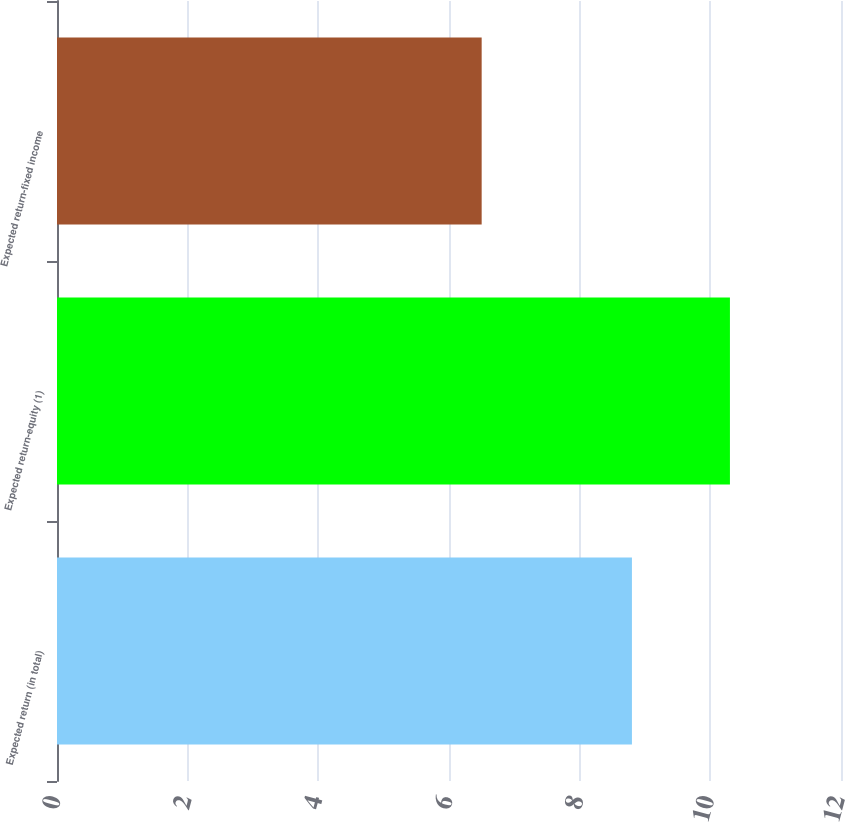Convert chart to OTSL. <chart><loc_0><loc_0><loc_500><loc_500><bar_chart><fcel>Expected return (in total)<fcel>Expected return-equity (1)<fcel>Expected return-fixed income<nl><fcel>8.8<fcel>10.3<fcel>6.5<nl></chart> 